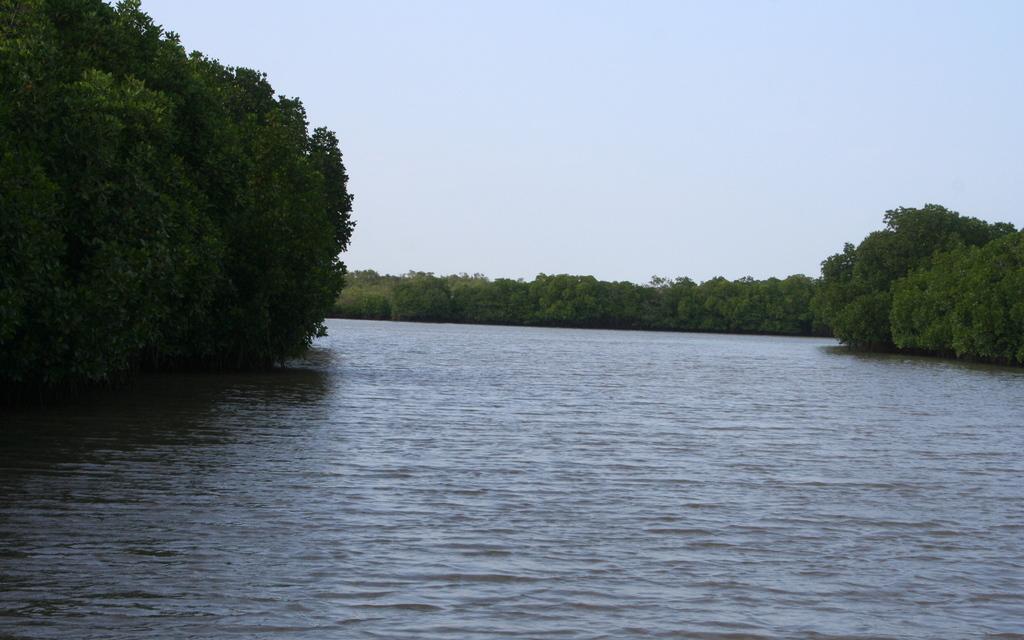How would you summarize this image in a sentence or two? In this image I can see there is a river and there are few trees on both sides of the river and the sky is clear. 